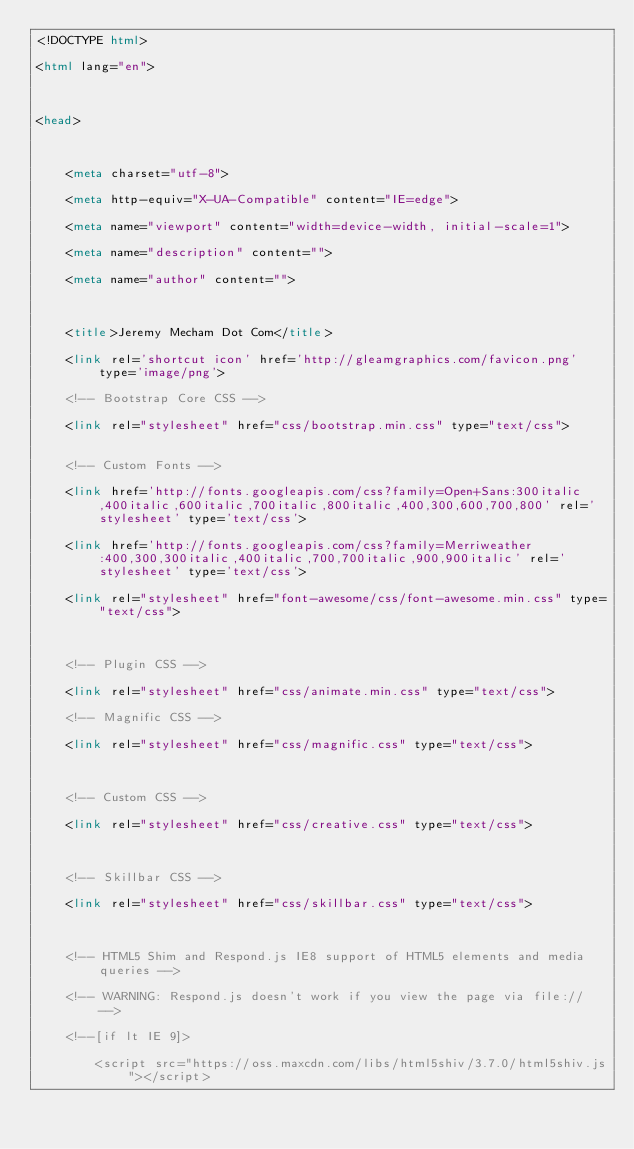Convert code to text. <code><loc_0><loc_0><loc_500><loc_500><_HTML_><!DOCTYPE html>

<html lang="en">



<head>



    <meta charset="utf-8">

    <meta http-equiv="X-UA-Compatible" content="IE=edge">

    <meta name="viewport" content="width=device-width, initial-scale=1">

    <meta name="description" content="">

    <meta name="author" content="">



    <title>Jeremy Mecham Dot Com</title>

    <link rel='shortcut icon' href='http://gleamgraphics.com/favicon.png' type='image/png'>

    <!-- Bootstrap Core CSS -->

    <link rel="stylesheet" href="css/bootstrap.min.css" type="text/css">


    <!-- Custom Fonts -->

    <link href='http://fonts.googleapis.com/css?family=Open+Sans:300italic,400italic,600italic,700italic,800italic,400,300,600,700,800' rel='stylesheet' type='text/css'>

    <link href='http://fonts.googleapis.com/css?family=Merriweather:400,300,300italic,400italic,700,700italic,900,900italic' rel='stylesheet' type='text/css'>

    <link rel="stylesheet" href="font-awesome/css/font-awesome.min.css" type="text/css">



    <!-- Plugin CSS -->

    <link rel="stylesheet" href="css/animate.min.css" type="text/css">

    <!-- Magnific CSS -->

    <link rel="stylesheet" href="css/magnific.css" type="text/css">



    <!-- Custom CSS -->

    <link rel="stylesheet" href="css/creative.css" type="text/css">



    <!-- Skillbar CSS -->

    <link rel="stylesheet" href="css/skillbar.css" type="text/css">



    <!-- HTML5 Shim and Respond.js IE8 support of HTML5 elements and media queries -->

    <!-- WARNING: Respond.js doesn't work if you view the page via file:// -->

    <!--[if lt IE 9]>

        <script src="https://oss.maxcdn.com/libs/html5shiv/3.7.0/html5shiv.js"></script>
</code> 